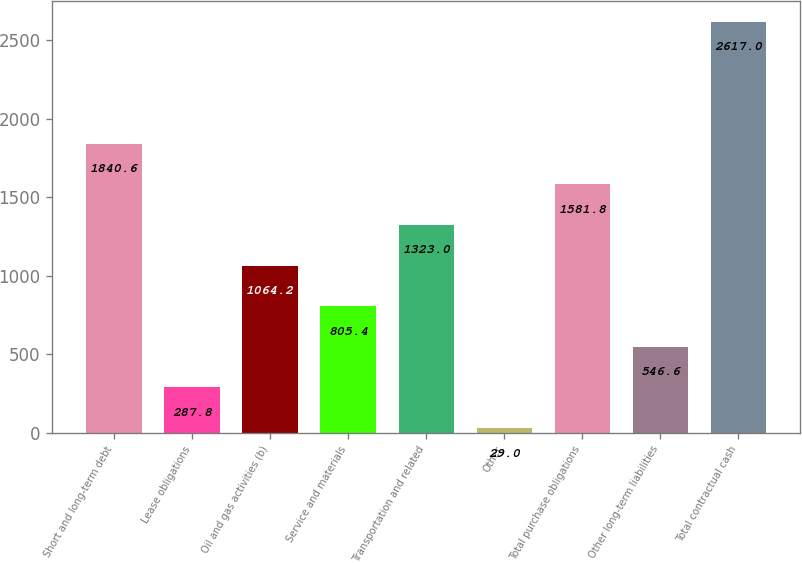Convert chart. <chart><loc_0><loc_0><loc_500><loc_500><bar_chart><fcel>Short and long-term debt<fcel>Lease obligations<fcel>Oil and gas activities (b)<fcel>Service and materials<fcel>Transportation and related<fcel>Other<fcel>Total purchase obligations<fcel>Other long-term liabilities<fcel>Total contractual cash<nl><fcel>1840.6<fcel>287.8<fcel>1064.2<fcel>805.4<fcel>1323<fcel>29<fcel>1581.8<fcel>546.6<fcel>2617<nl></chart> 